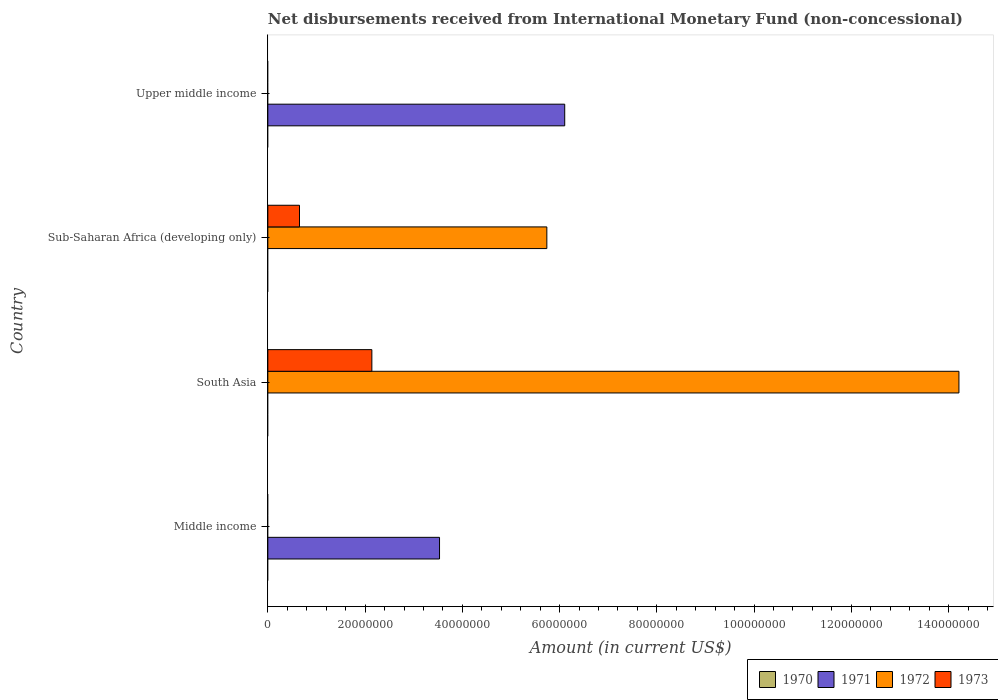How many different coloured bars are there?
Provide a short and direct response. 3. Are the number of bars per tick equal to the number of legend labels?
Your response must be concise. No. Are the number of bars on each tick of the Y-axis equal?
Your answer should be compact. No. How many bars are there on the 2nd tick from the bottom?
Offer a terse response. 2. What is the label of the 2nd group of bars from the top?
Your response must be concise. Sub-Saharan Africa (developing only). Across all countries, what is the maximum amount of disbursements received from International Monetary Fund in 1973?
Ensure brevity in your answer.  2.14e+07. Across all countries, what is the minimum amount of disbursements received from International Monetary Fund in 1973?
Ensure brevity in your answer.  0. In which country was the amount of disbursements received from International Monetary Fund in 1971 maximum?
Offer a very short reply. Upper middle income. What is the difference between the amount of disbursements received from International Monetary Fund in 1972 in South Asia and that in Sub-Saharan Africa (developing only)?
Ensure brevity in your answer.  8.48e+07. What is the difference between the amount of disbursements received from International Monetary Fund in 1973 in South Asia and the amount of disbursements received from International Monetary Fund in 1970 in Upper middle income?
Offer a terse response. 2.14e+07. What is the average amount of disbursements received from International Monetary Fund in 1971 per country?
Offer a very short reply. 2.41e+07. What is the difference between the amount of disbursements received from International Monetary Fund in 1973 and amount of disbursements received from International Monetary Fund in 1972 in South Asia?
Give a very brief answer. -1.21e+08. Is the amount of disbursements received from International Monetary Fund in 1971 in Middle income less than that in Upper middle income?
Provide a succinct answer. Yes. Is the difference between the amount of disbursements received from International Monetary Fund in 1973 in South Asia and Sub-Saharan Africa (developing only) greater than the difference between the amount of disbursements received from International Monetary Fund in 1972 in South Asia and Sub-Saharan Africa (developing only)?
Keep it short and to the point. No. What is the difference between the highest and the lowest amount of disbursements received from International Monetary Fund in 1971?
Keep it short and to the point. 6.11e+07. Is the sum of the amount of disbursements received from International Monetary Fund in 1971 in Middle income and Upper middle income greater than the maximum amount of disbursements received from International Monetary Fund in 1973 across all countries?
Your response must be concise. Yes. Is it the case that in every country, the sum of the amount of disbursements received from International Monetary Fund in 1973 and amount of disbursements received from International Monetary Fund in 1971 is greater than the amount of disbursements received from International Monetary Fund in 1972?
Keep it short and to the point. No. How many bars are there?
Make the answer very short. 6. Are all the bars in the graph horizontal?
Your answer should be compact. Yes. What is the difference between two consecutive major ticks on the X-axis?
Ensure brevity in your answer.  2.00e+07. Does the graph contain any zero values?
Provide a succinct answer. Yes. Does the graph contain grids?
Your response must be concise. No. Where does the legend appear in the graph?
Offer a very short reply. Bottom right. What is the title of the graph?
Give a very brief answer. Net disbursements received from International Monetary Fund (non-concessional). What is the label or title of the X-axis?
Offer a terse response. Amount (in current US$). What is the label or title of the Y-axis?
Your answer should be compact. Country. What is the Amount (in current US$) of 1971 in Middle income?
Provide a short and direct response. 3.53e+07. What is the Amount (in current US$) of 1971 in South Asia?
Provide a succinct answer. 0. What is the Amount (in current US$) of 1972 in South Asia?
Provide a succinct answer. 1.42e+08. What is the Amount (in current US$) of 1973 in South Asia?
Your response must be concise. 2.14e+07. What is the Amount (in current US$) in 1970 in Sub-Saharan Africa (developing only)?
Make the answer very short. 0. What is the Amount (in current US$) of 1971 in Sub-Saharan Africa (developing only)?
Keep it short and to the point. 0. What is the Amount (in current US$) in 1972 in Sub-Saharan Africa (developing only)?
Your answer should be very brief. 5.74e+07. What is the Amount (in current US$) in 1973 in Sub-Saharan Africa (developing only)?
Provide a short and direct response. 6.51e+06. What is the Amount (in current US$) of 1970 in Upper middle income?
Keep it short and to the point. 0. What is the Amount (in current US$) in 1971 in Upper middle income?
Offer a terse response. 6.11e+07. What is the Amount (in current US$) of 1972 in Upper middle income?
Your answer should be compact. 0. Across all countries, what is the maximum Amount (in current US$) of 1971?
Your response must be concise. 6.11e+07. Across all countries, what is the maximum Amount (in current US$) in 1972?
Your answer should be compact. 1.42e+08. Across all countries, what is the maximum Amount (in current US$) of 1973?
Provide a short and direct response. 2.14e+07. Across all countries, what is the minimum Amount (in current US$) of 1971?
Give a very brief answer. 0. Across all countries, what is the minimum Amount (in current US$) of 1973?
Provide a succinct answer. 0. What is the total Amount (in current US$) of 1971 in the graph?
Give a very brief answer. 9.64e+07. What is the total Amount (in current US$) of 1972 in the graph?
Provide a short and direct response. 2.00e+08. What is the total Amount (in current US$) of 1973 in the graph?
Your answer should be very brief. 2.79e+07. What is the difference between the Amount (in current US$) in 1971 in Middle income and that in Upper middle income?
Offer a very short reply. -2.57e+07. What is the difference between the Amount (in current US$) of 1972 in South Asia and that in Sub-Saharan Africa (developing only)?
Your answer should be compact. 8.48e+07. What is the difference between the Amount (in current US$) in 1973 in South Asia and that in Sub-Saharan Africa (developing only)?
Your response must be concise. 1.49e+07. What is the difference between the Amount (in current US$) of 1971 in Middle income and the Amount (in current US$) of 1972 in South Asia?
Ensure brevity in your answer.  -1.07e+08. What is the difference between the Amount (in current US$) of 1971 in Middle income and the Amount (in current US$) of 1973 in South Asia?
Provide a short and direct response. 1.39e+07. What is the difference between the Amount (in current US$) of 1971 in Middle income and the Amount (in current US$) of 1972 in Sub-Saharan Africa (developing only)?
Offer a terse response. -2.21e+07. What is the difference between the Amount (in current US$) in 1971 in Middle income and the Amount (in current US$) in 1973 in Sub-Saharan Africa (developing only)?
Ensure brevity in your answer.  2.88e+07. What is the difference between the Amount (in current US$) of 1972 in South Asia and the Amount (in current US$) of 1973 in Sub-Saharan Africa (developing only)?
Your answer should be very brief. 1.36e+08. What is the average Amount (in current US$) in 1971 per country?
Your answer should be very brief. 2.41e+07. What is the average Amount (in current US$) of 1972 per country?
Your answer should be very brief. 4.99e+07. What is the average Amount (in current US$) of 1973 per country?
Make the answer very short. 6.98e+06. What is the difference between the Amount (in current US$) of 1972 and Amount (in current US$) of 1973 in South Asia?
Your answer should be compact. 1.21e+08. What is the difference between the Amount (in current US$) of 1972 and Amount (in current US$) of 1973 in Sub-Saharan Africa (developing only)?
Provide a succinct answer. 5.09e+07. What is the ratio of the Amount (in current US$) in 1971 in Middle income to that in Upper middle income?
Your answer should be very brief. 0.58. What is the ratio of the Amount (in current US$) of 1972 in South Asia to that in Sub-Saharan Africa (developing only)?
Provide a succinct answer. 2.48. What is the ratio of the Amount (in current US$) in 1973 in South Asia to that in Sub-Saharan Africa (developing only)?
Your answer should be compact. 3.29. What is the difference between the highest and the lowest Amount (in current US$) of 1971?
Give a very brief answer. 6.11e+07. What is the difference between the highest and the lowest Amount (in current US$) of 1972?
Your answer should be very brief. 1.42e+08. What is the difference between the highest and the lowest Amount (in current US$) of 1973?
Give a very brief answer. 2.14e+07. 